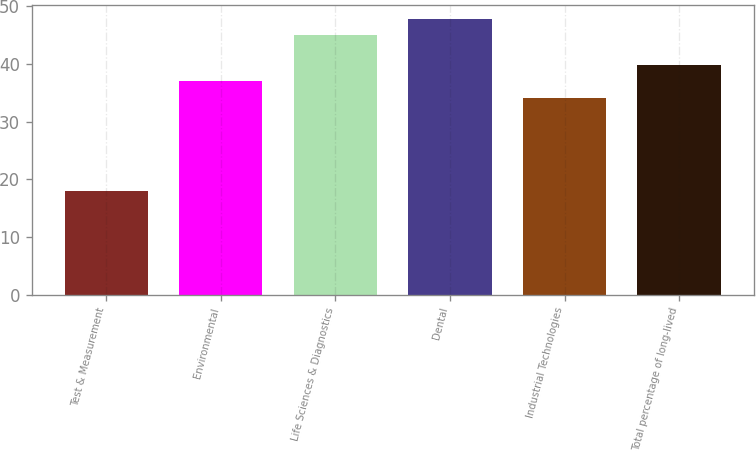Convert chart. <chart><loc_0><loc_0><loc_500><loc_500><bar_chart><fcel>Test & Measurement<fcel>Environmental<fcel>Life Sciences & Diagnostics<fcel>Dental<fcel>Industrial Technologies<fcel>Total percentage of long-lived<nl><fcel>18<fcel>37<fcel>45<fcel>47.8<fcel>34<fcel>39.8<nl></chart> 